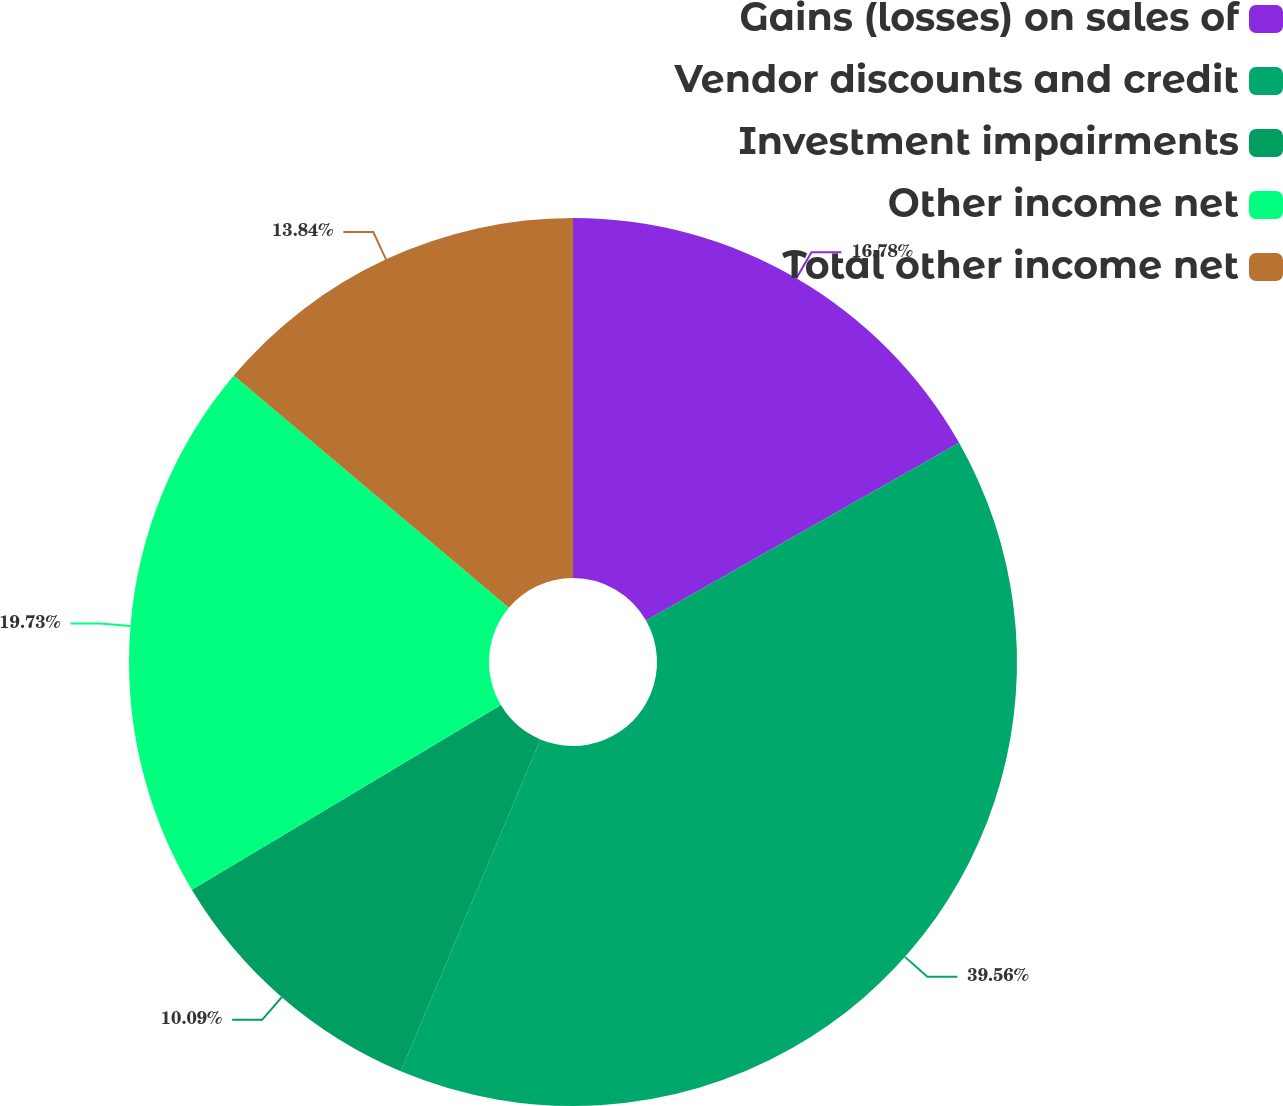Convert chart to OTSL. <chart><loc_0><loc_0><loc_500><loc_500><pie_chart><fcel>Gains (losses) on sales of<fcel>Vendor discounts and credit<fcel>Investment impairments<fcel>Other income net<fcel>Total other income net<nl><fcel>16.78%<fcel>39.56%<fcel>10.09%<fcel>19.73%<fcel>13.84%<nl></chart> 